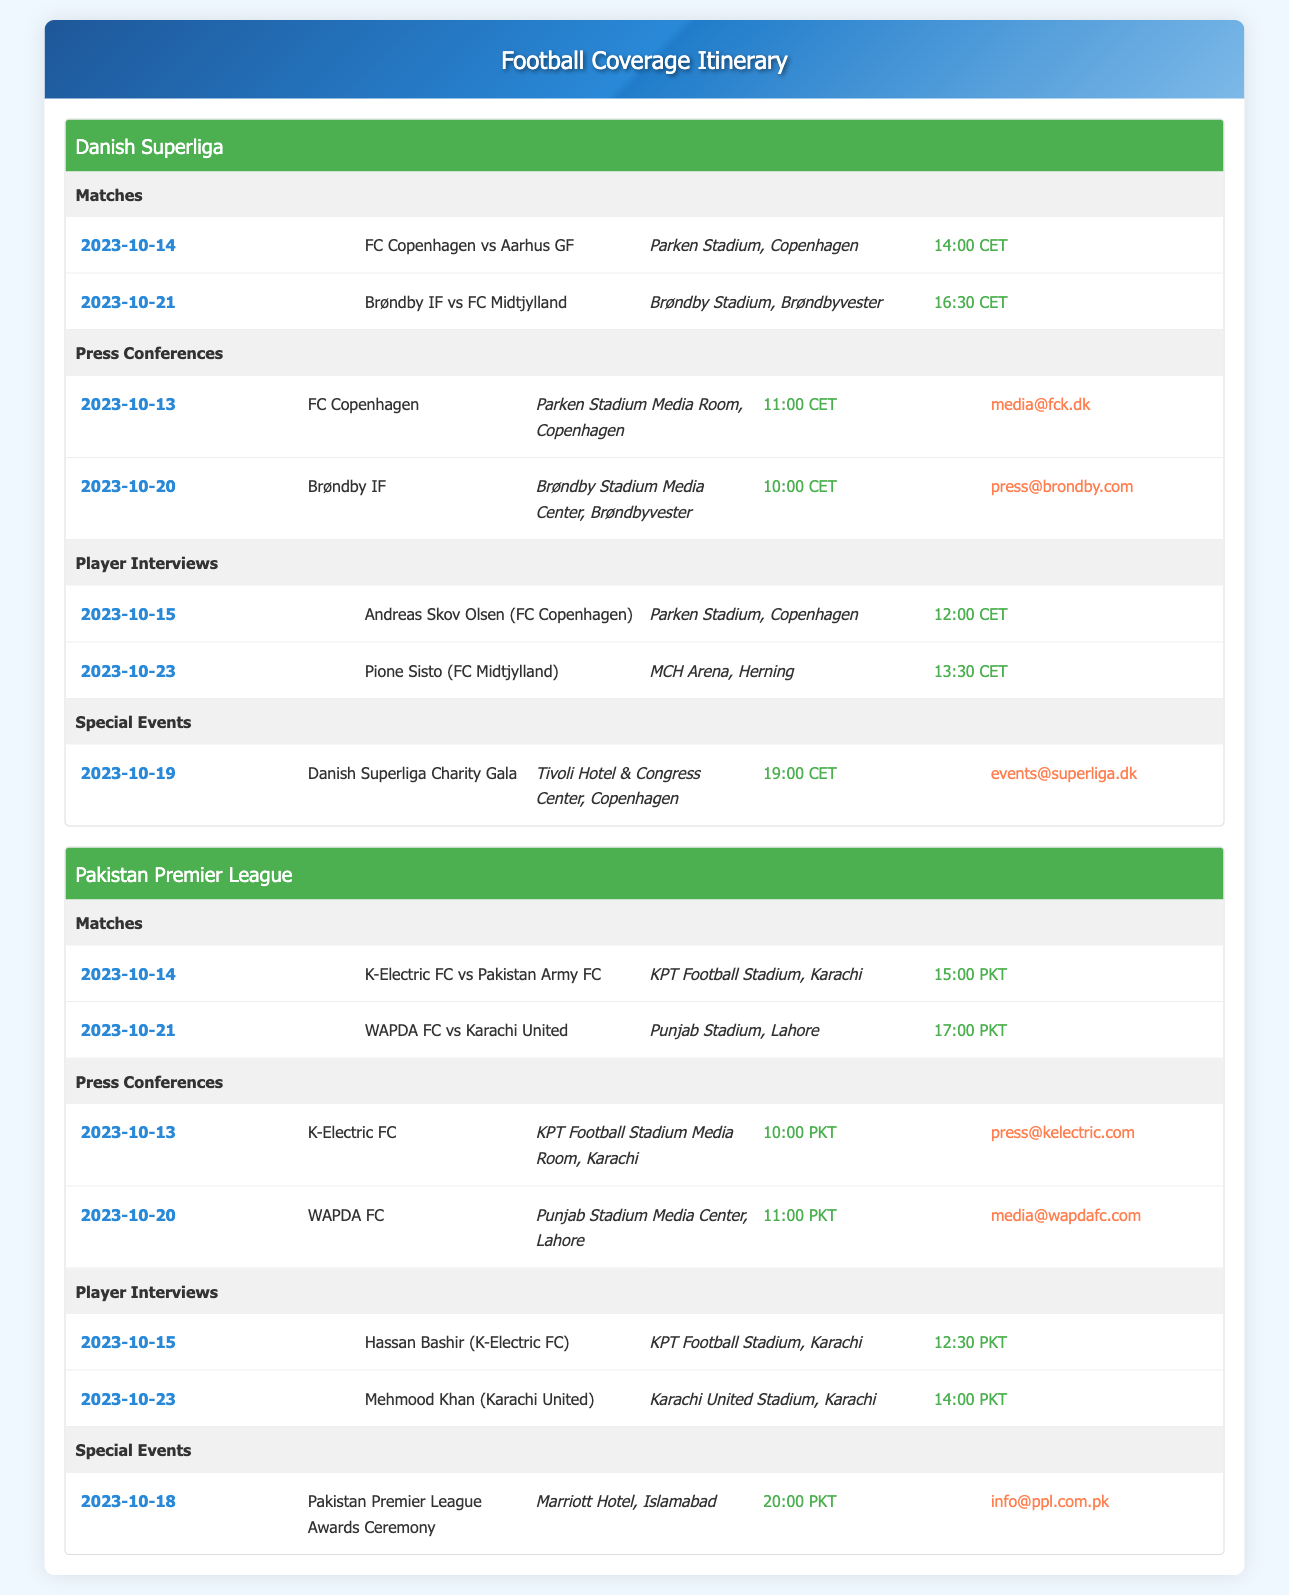what is the date of the match between FC Copenhagen and Aarhus GF? The date of the match can be found in the Matches section of the Danish Superliga, listed as October 14, 2023.
Answer: 2023-10-14 where is the Pakistan Premier League Awards Ceremony taking place? The location of the Pakistan Premier League Awards Ceremony is mentioned in the Special Events section under Pakistan Premier League.
Answer: Marriott Hotel, Islamabad what time is the press conference for Brøndby IF scheduled? The timing for the Brøndby IF press conference is available in the Press Conferences section of the Danish Superliga itinerary.
Answer: 10:00 CET who is the player interviewed on 2023-10-15 from K-Electric FC? The player interview details mention the player being interviewed from K-Electric FC on that date.
Answer: Hassan Bashir how many matches are listed for the Pakistan Premier League? The number of matches could be counted from the Matches section under the Pakistan Premier League. There are two matches listed.
Answer: 2 what event is scheduled for 2023-10-19 in the Danish Superliga? The event scheduled on that date is highlighted in the Special Events section of the Danish Superliga itinerary.
Answer: Danish Superliga Charity Gala when is the player interview with Pione Sisto (FC Midtjylland) taking place? The date for the player interview can be found in the Player Interviews section of the Danish Superliga.
Answer: 2023-10-23 what is the contact email for press inquiries regarding K-Electric FC? The contact email for press inquiries is stated in the Press Conferences section for K-Electric FC.
Answer: press@kelectric.com 